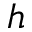Convert formula to latex. <formula><loc_0><loc_0><loc_500><loc_500>h</formula> 